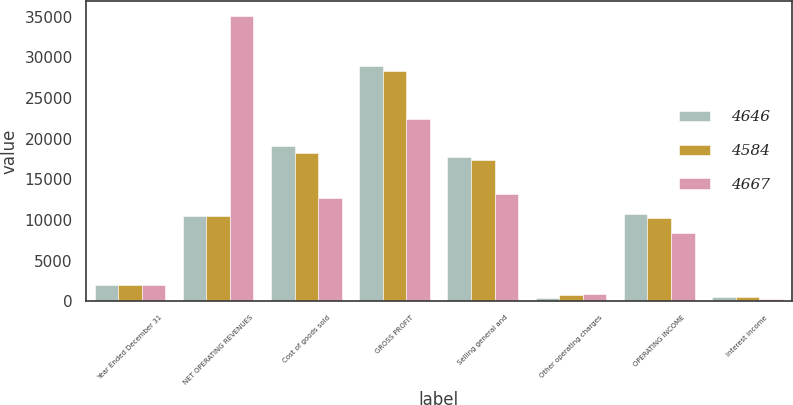Convert chart. <chart><loc_0><loc_0><loc_500><loc_500><stacked_bar_chart><ecel><fcel>Year Ended December 31<fcel>NET OPERATING REVENUES<fcel>Cost of goods sold<fcel>GROSS PROFIT<fcel>Selling general and<fcel>Other operating charges<fcel>OPERATING INCOME<fcel>Interest income<nl><fcel>4646<fcel>2012<fcel>10476<fcel>19053<fcel>28964<fcel>17738<fcel>447<fcel>10779<fcel>471<nl><fcel>4584<fcel>2011<fcel>10476<fcel>18215<fcel>28327<fcel>17422<fcel>732<fcel>10173<fcel>483<nl><fcel>4667<fcel>2010<fcel>35119<fcel>12693<fcel>22426<fcel>13194<fcel>819<fcel>8413<fcel>317<nl></chart> 